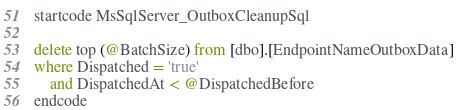<code> <loc_0><loc_0><loc_500><loc_500><_SQL_>startcode MsSqlServer_OutboxCleanupSql

delete top (@BatchSize) from [dbo].[EndpointNameOutboxData]
where Dispatched = 'true'
    and DispatchedAt < @DispatchedBefore
endcode
</code> 